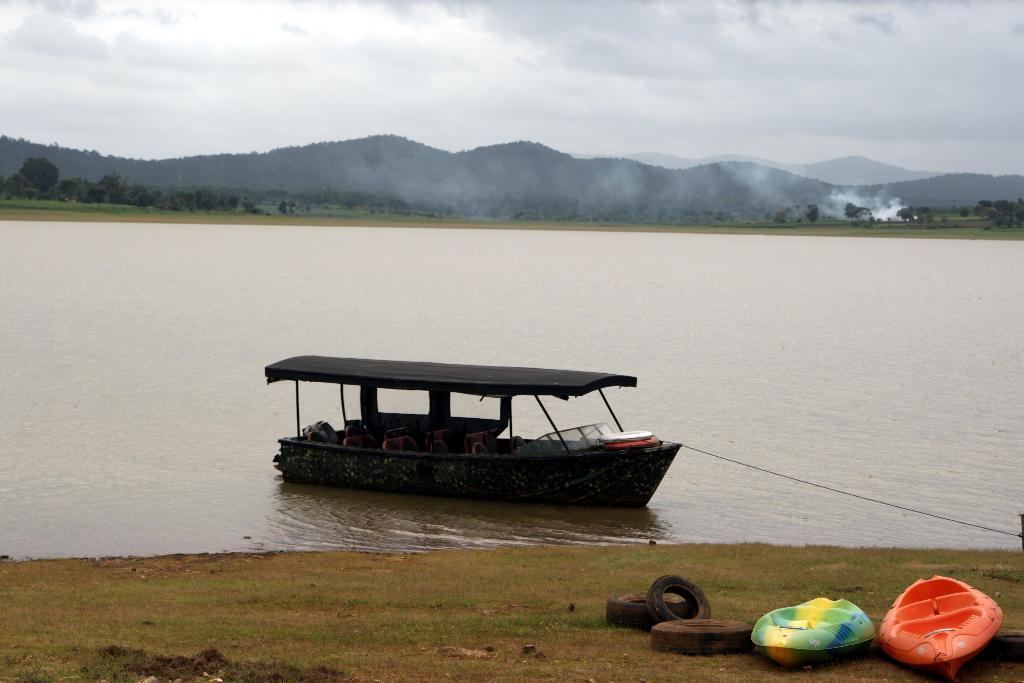What can be seen in the image that is used for transportation on water? There are boats in the image. What objects are placed on the grass in the image? There are tires on the grass in the image. Can you describe the location of one of the boats in the image? There is a boat on the water in the image. What type of natural features can be seen in the background of the image? There are trees, mountains, and smoke visible in the background of the image. What is the condition of the sky in the image? The sky with clouds is visible in the background of the image. What type of verse can be seen written on the sand in the image? There is no sand or verse present in the image. What route are the boats taking in the image? The image does not provide information about the route the boats are taking; it only shows the boats on the water. 